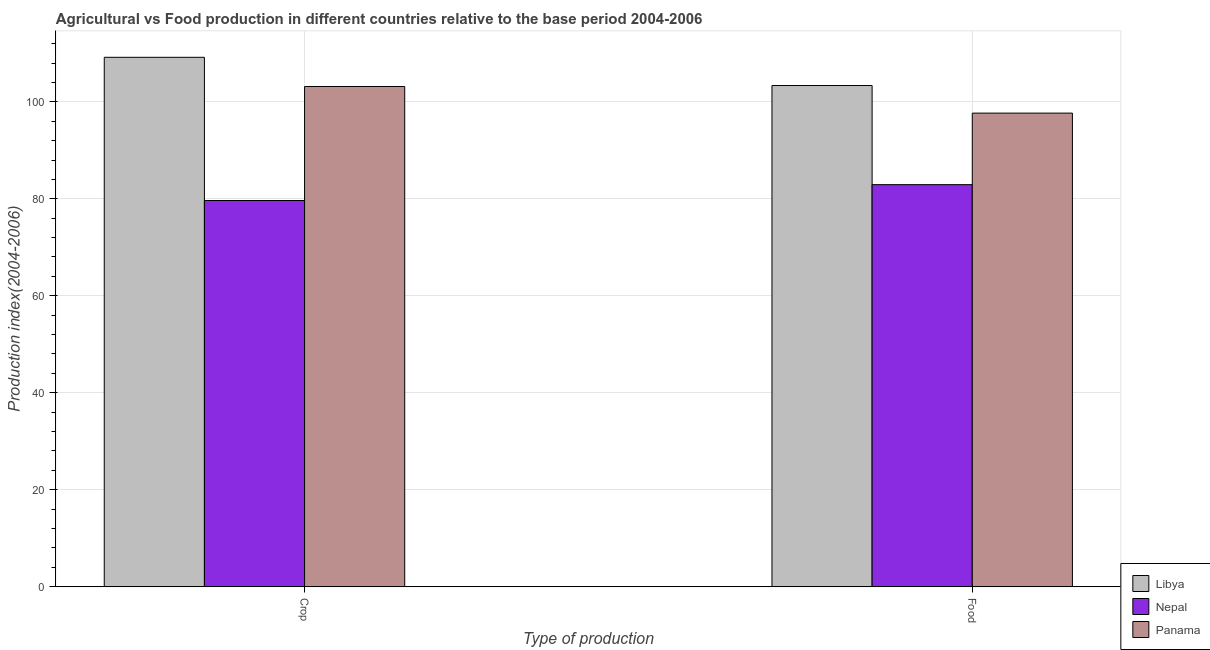Are the number of bars per tick equal to the number of legend labels?
Make the answer very short. Yes. What is the label of the 2nd group of bars from the left?
Provide a succinct answer. Food. What is the crop production index in Panama?
Provide a succinct answer. 103.16. Across all countries, what is the maximum crop production index?
Keep it short and to the point. 109.18. Across all countries, what is the minimum food production index?
Your response must be concise. 82.92. In which country was the crop production index maximum?
Give a very brief answer. Libya. In which country was the food production index minimum?
Give a very brief answer. Nepal. What is the total food production index in the graph?
Keep it short and to the point. 283.95. What is the difference between the crop production index in Nepal and that in Panama?
Make the answer very short. -23.51. What is the difference between the food production index in Nepal and the crop production index in Libya?
Provide a succinct answer. -26.26. What is the average food production index per country?
Offer a terse response. 94.65. What is the difference between the crop production index and food production index in Nepal?
Your answer should be compact. -3.27. What is the ratio of the food production index in Panama to that in Nepal?
Provide a succinct answer. 1.18. What does the 1st bar from the left in Crop represents?
Provide a short and direct response. Libya. What does the 2nd bar from the right in Food represents?
Ensure brevity in your answer.  Nepal. How many countries are there in the graph?
Give a very brief answer. 3. How many legend labels are there?
Give a very brief answer. 3. What is the title of the graph?
Your answer should be compact. Agricultural vs Food production in different countries relative to the base period 2004-2006. Does "Bermuda" appear as one of the legend labels in the graph?
Keep it short and to the point. No. What is the label or title of the X-axis?
Your answer should be compact. Type of production. What is the label or title of the Y-axis?
Keep it short and to the point. Production index(2004-2006). What is the Production index(2004-2006) in Libya in Crop?
Provide a short and direct response. 109.18. What is the Production index(2004-2006) in Nepal in Crop?
Make the answer very short. 79.65. What is the Production index(2004-2006) in Panama in Crop?
Offer a very short reply. 103.16. What is the Production index(2004-2006) in Libya in Food?
Your answer should be compact. 103.36. What is the Production index(2004-2006) of Nepal in Food?
Your response must be concise. 82.92. What is the Production index(2004-2006) of Panama in Food?
Provide a succinct answer. 97.67. Across all Type of production, what is the maximum Production index(2004-2006) in Libya?
Offer a very short reply. 109.18. Across all Type of production, what is the maximum Production index(2004-2006) of Nepal?
Provide a short and direct response. 82.92. Across all Type of production, what is the maximum Production index(2004-2006) of Panama?
Ensure brevity in your answer.  103.16. Across all Type of production, what is the minimum Production index(2004-2006) of Libya?
Offer a very short reply. 103.36. Across all Type of production, what is the minimum Production index(2004-2006) of Nepal?
Ensure brevity in your answer.  79.65. Across all Type of production, what is the minimum Production index(2004-2006) of Panama?
Provide a short and direct response. 97.67. What is the total Production index(2004-2006) of Libya in the graph?
Give a very brief answer. 212.54. What is the total Production index(2004-2006) of Nepal in the graph?
Your answer should be compact. 162.57. What is the total Production index(2004-2006) of Panama in the graph?
Your answer should be very brief. 200.83. What is the difference between the Production index(2004-2006) of Libya in Crop and that in Food?
Keep it short and to the point. 5.82. What is the difference between the Production index(2004-2006) of Nepal in Crop and that in Food?
Make the answer very short. -3.27. What is the difference between the Production index(2004-2006) in Panama in Crop and that in Food?
Keep it short and to the point. 5.49. What is the difference between the Production index(2004-2006) of Libya in Crop and the Production index(2004-2006) of Nepal in Food?
Offer a very short reply. 26.26. What is the difference between the Production index(2004-2006) in Libya in Crop and the Production index(2004-2006) in Panama in Food?
Ensure brevity in your answer.  11.51. What is the difference between the Production index(2004-2006) of Nepal in Crop and the Production index(2004-2006) of Panama in Food?
Make the answer very short. -18.02. What is the average Production index(2004-2006) of Libya per Type of production?
Offer a very short reply. 106.27. What is the average Production index(2004-2006) in Nepal per Type of production?
Give a very brief answer. 81.28. What is the average Production index(2004-2006) in Panama per Type of production?
Provide a succinct answer. 100.42. What is the difference between the Production index(2004-2006) of Libya and Production index(2004-2006) of Nepal in Crop?
Keep it short and to the point. 29.53. What is the difference between the Production index(2004-2006) in Libya and Production index(2004-2006) in Panama in Crop?
Make the answer very short. 6.02. What is the difference between the Production index(2004-2006) in Nepal and Production index(2004-2006) in Panama in Crop?
Ensure brevity in your answer.  -23.51. What is the difference between the Production index(2004-2006) of Libya and Production index(2004-2006) of Nepal in Food?
Make the answer very short. 20.44. What is the difference between the Production index(2004-2006) in Libya and Production index(2004-2006) in Panama in Food?
Offer a terse response. 5.69. What is the difference between the Production index(2004-2006) of Nepal and Production index(2004-2006) of Panama in Food?
Offer a terse response. -14.75. What is the ratio of the Production index(2004-2006) of Libya in Crop to that in Food?
Keep it short and to the point. 1.06. What is the ratio of the Production index(2004-2006) of Nepal in Crop to that in Food?
Your answer should be very brief. 0.96. What is the ratio of the Production index(2004-2006) in Panama in Crop to that in Food?
Offer a terse response. 1.06. What is the difference between the highest and the second highest Production index(2004-2006) of Libya?
Your answer should be compact. 5.82. What is the difference between the highest and the second highest Production index(2004-2006) in Nepal?
Offer a very short reply. 3.27. What is the difference between the highest and the second highest Production index(2004-2006) in Panama?
Offer a terse response. 5.49. What is the difference between the highest and the lowest Production index(2004-2006) of Libya?
Give a very brief answer. 5.82. What is the difference between the highest and the lowest Production index(2004-2006) of Nepal?
Offer a terse response. 3.27. What is the difference between the highest and the lowest Production index(2004-2006) in Panama?
Your answer should be very brief. 5.49. 